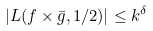<formula> <loc_0><loc_0><loc_500><loc_500>| L ( f \times \bar { g } , 1 / 2 ) | \leq k ^ { \delta }</formula> 